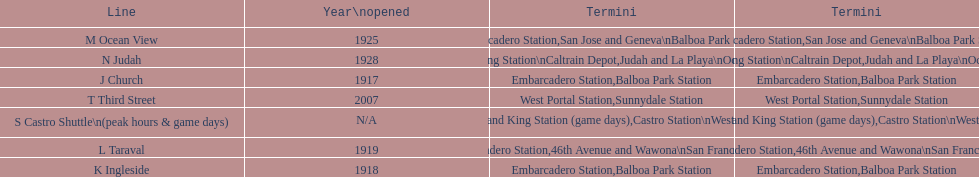On game days, which line do you want to use? S Castro Shuttle. 